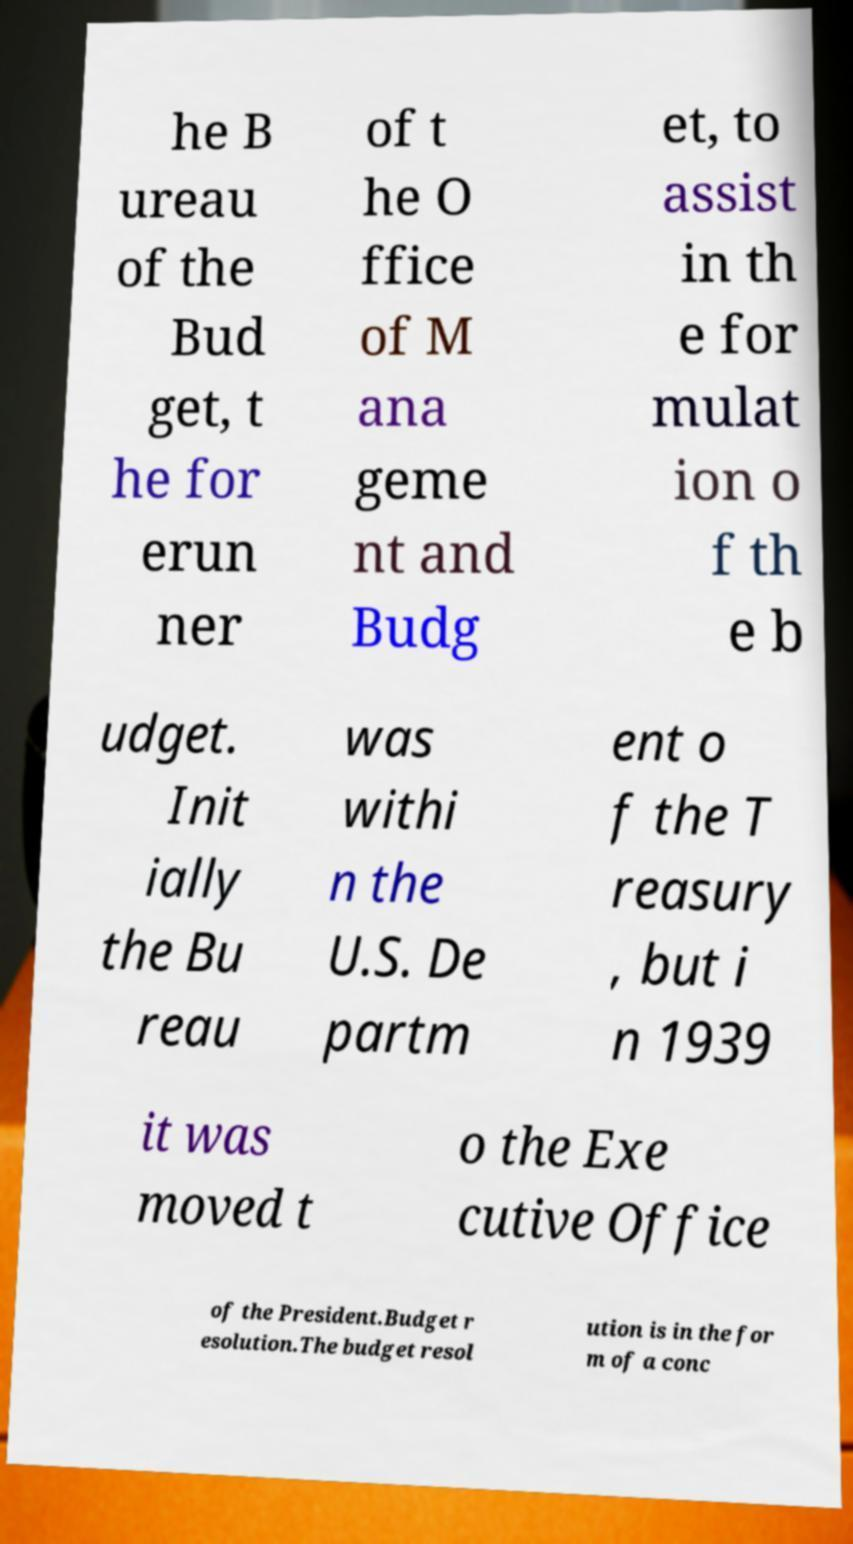Could you assist in decoding the text presented in this image and type it out clearly? he B ureau of the Bud get, t he for erun ner of t he O ffice of M ana geme nt and Budg et, to assist in th e for mulat ion o f th e b udget. Init ially the Bu reau was withi n the U.S. De partm ent o f the T reasury , but i n 1939 it was moved t o the Exe cutive Office of the President.Budget r esolution.The budget resol ution is in the for m of a conc 